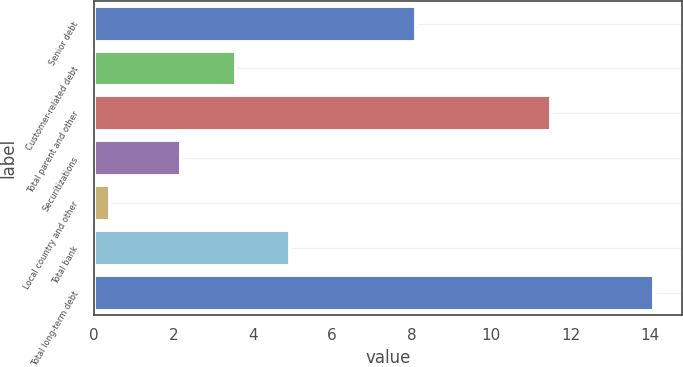Convert chart to OTSL. <chart><loc_0><loc_0><loc_500><loc_500><bar_chart><fcel>Senior debt<fcel>Customer-related debt<fcel>Total parent and other<fcel>Securitizations<fcel>Local country and other<fcel>Total bank<fcel>Total long-term debt<nl><fcel>8.1<fcel>3.57<fcel>11.5<fcel>2.2<fcel>0.4<fcel>4.94<fcel>14.1<nl></chart> 